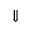Convert formula to latex. <formula><loc_0><loc_0><loc_500><loc_500>\Downarrow</formula> 